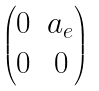Convert formula to latex. <formula><loc_0><loc_0><loc_500><loc_500>\begin{pmatrix} 0 & a _ { e } \\ 0 & 0 \end{pmatrix}</formula> 